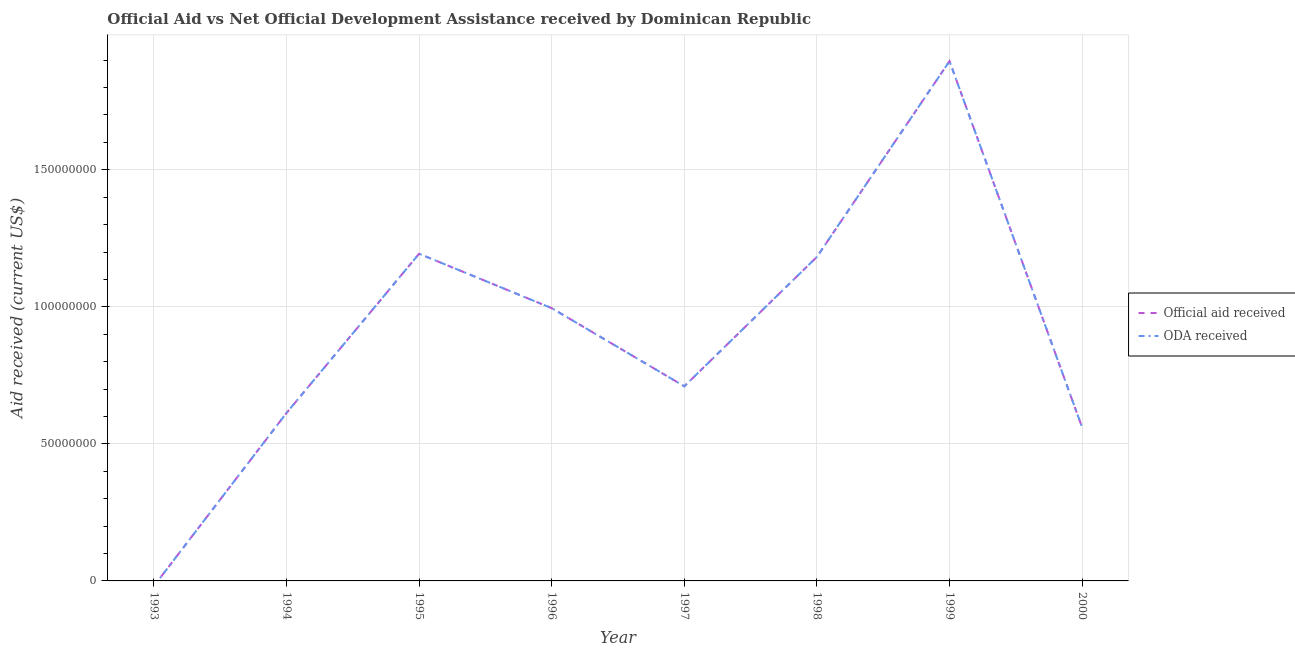How many different coloured lines are there?
Your answer should be very brief. 2. What is the official aid received in 1994?
Give a very brief answer. 6.13e+07. Across all years, what is the maximum oda received?
Your response must be concise. 1.90e+08. In which year was the official aid received maximum?
Keep it short and to the point. 1999. What is the total oda received in the graph?
Keep it short and to the point. 7.15e+08. What is the difference between the official aid received in 1995 and that in 1999?
Ensure brevity in your answer.  -7.03e+07. What is the difference between the official aid received in 1997 and the oda received in 1994?
Offer a very short reply. 9.74e+06. What is the average official aid received per year?
Give a very brief answer. 8.94e+07. In the year 1997, what is the difference between the official aid received and oda received?
Keep it short and to the point. 0. In how many years, is the oda received greater than 160000000 US$?
Make the answer very short. 1. What is the ratio of the oda received in 1994 to that in 1996?
Ensure brevity in your answer.  0.62. What is the difference between the highest and the second highest official aid received?
Your response must be concise. 7.03e+07. What is the difference between the highest and the lowest official aid received?
Provide a short and direct response. 1.90e+08. Does the official aid received monotonically increase over the years?
Offer a terse response. No. Is the oda received strictly greater than the official aid received over the years?
Your answer should be compact. No. How many lines are there?
Provide a short and direct response. 2. What is the difference between two consecutive major ticks on the Y-axis?
Offer a terse response. 5.00e+07. Does the graph contain any zero values?
Offer a terse response. Yes. Does the graph contain grids?
Offer a very short reply. Yes. How are the legend labels stacked?
Offer a terse response. Vertical. What is the title of the graph?
Your response must be concise. Official Aid vs Net Official Development Assistance received by Dominican Republic . What is the label or title of the X-axis?
Make the answer very short. Year. What is the label or title of the Y-axis?
Provide a short and direct response. Aid received (current US$). What is the Aid received (current US$) in Official aid received in 1993?
Your response must be concise. 0. What is the Aid received (current US$) in Official aid received in 1994?
Provide a succinct answer. 6.13e+07. What is the Aid received (current US$) in ODA received in 1994?
Your answer should be compact. 6.13e+07. What is the Aid received (current US$) in Official aid received in 1995?
Offer a very short reply. 1.19e+08. What is the Aid received (current US$) in ODA received in 1995?
Your answer should be compact. 1.19e+08. What is the Aid received (current US$) of Official aid received in 1996?
Keep it short and to the point. 9.95e+07. What is the Aid received (current US$) of ODA received in 1996?
Offer a terse response. 9.95e+07. What is the Aid received (current US$) of Official aid received in 1997?
Your response must be concise. 7.10e+07. What is the Aid received (current US$) of ODA received in 1997?
Your answer should be compact. 7.10e+07. What is the Aid received (current US$) of Official aid received in 1998?
Your answer should be very brief. 1.18e+08. What is the Aid received (current US$) in ODA received in 1998?
Ensure brevity in your answer.  1.18e+08. What is the Aid received (current US$) of Official aid received in 1999?
Your answer should be compact. 1.90e+08. What is the Aid received (current US$) of ODA received in 1999?
Your answer should be very brief. 1.90e+08. What is the Aid received (current US$) of Official aid received in 2000?
Provide a short and direct response. 5.60e+07. What is the Aid received (current US$) of ODA received in 2000?
Provide a short and direct response. 5.60e+07. Across all years, what is the maximum Aid received (current US$) in Official aid received?
Your answer should be very brief. 1.90e+08. Across all years, what is the maximum Aid received (current US$) in ODA received?
Your answer should be very brief. 1.90e+08. Across all years, what is the minimum Aid received (current US$) in ODA received?
Offer a very short reply. 0. What is the total Aid received (current US$) of Official aid received in the graph?
Offer a terse response. 7.15e+08. What is the total Aid received (current US$) in ODA received in the graph?
Give a very brief answer. 7.15e+08. What is the difference between the Aid received (current US$) of Official aid received in 1994 and that in 1995?
Your answer should be compact. -5.81e+07. What is the difference between the Aid received (current US$) in ODA received in 1994 and that in 1995?
Your answer should be compact. -5.81e+07. What is the difference between the Aid received (current US$) of Official aid received in 1994 and that in 1996?
Offer a terse response. -3.82e+07. What is the difference between the Aid received (current US$) in ODA received in 1994 and that in 1996?
Your response must be concise. -3.82e+07. What is the difference between the Aid received (current US$) of Official aid received in 1994 and that in 1997?
Ensure brevity in your answer.  -9.74e+06. What is the difference between the Aid received (current US$) of ODA received in 1994 and that in 1997?
Offer a very short reply. -9.74e+06. What is the difference between the Aid received (current US$) of Official aid received in 1994 and that in 1998?
Offer a terse response. -5.70e+07. What is the difference between the Aid received (current US$) of ODA received in 1994 and that in 1998?
Offer a terse response. -5.70e+07. What is the difference between the Aid received (current US$) of Official aid received in 1994 and that in 1999?
Provide a succinct answer. -1.28e+08. What is the difference between the Aid received (current US$) in ODA received in 1994 and that in 1999?
Keep it short and to the point. -1.28e+08. What is the difference between the Aid received (current US$) of Official aid received in 1994 and that in 2000?
Keep it short and to the point. 5.27e+06. What is the difference between the Aid received (current US$) of ODA received in 1994 and that in 2000?
Offer a very short reply. 5.27e+06. What is the difference between the Aid received (current US$) in Official aid received in 1995 and that in 1996?
Give a very brief answer. 1.98e+07. What is the difference between the Aid received (current US$) of ODA received in 1995 and that in 1996?
Keep it short and to the point. 1.98e+07. What is the difference between the Aid received (current US$) of Official aid received in 1995 and that in 1997?
Your answer should be very brief. 4.84e+07. What is the difference between the Aid received (current US$) in ODA received in 1995 and that in 1997?
Provide a succinct answer. 4.84e+07. What is the difference between the Aid received (current US$) of Official aid received in 1995 and that in 1998?
Offer a terse response. 1.13e+06. What is the difference between the Aid received (current US$) in ODA received in 1995 and that in 1998?
Provide a succinct answer. 1.13e+06. What is the difference between the Aid received (current US$) in Official aid received in 1995 and that in 1999?
Provide a succinct answer. -7.03e+07. What is the difference between the Aid received (current US$) in ODA received in 1995 and that in 1999?
Offer a very short reply. -7.03e+07. What is the difference between the Aid received (current US$) in Official aid received in 1995 and that in 2000?
Your answer should be compact. 6.34e+07. What is the difference between the Aid received (current US$) of ODA received in 1995 and that in 2000?
Your answer should be very brief. 6.34e+07. What is the difference between the Aid received (current US$) of Official aid received in 1996 and that in 1997?
Offer a very short reply. 2.85e+07. What is the difference between the Aid received (current US$) of ODA received in 1996 and that in 1997?
Offer a very short reply. 2.85e+07. What is the difference between the Aid received (current US$) in Official aid received in 1996 and that in 1998?
Your answer should be compact. -1.87e+07. What is the difference between the Aid received (current US$) in ODA received in 1996 and that in 1998?
Provide a succinct answer. -1.87e+07. What is the difference between the Aid received (current US$) of Official aid received in 1996 and that in 1999?
Give a very brief answer. -9.01e+07. What is the difference between the Aid received (current US$) of ODA received in 1996 and that in 1999?
Keep it short and to the point. -9.01e+07. What is the difference between the Aid received (current US$) of Official aid received in 1996 and that in 2000?
Offer a terse response. 4.35e+07. What is the difference between the Aid received (current US$) of ODA received in 1996 and that in 2000?
Make the answer very short. 4.35e+07. What is the difference between the Aid received (current US$) in Official aid received in 1997 and that in 1998?
Your answer should be compact. -4.72e+07. What is the difference between the Aid received (current US$) in ODA received in 1997 and that in 1998?
Ensure brevity in your answer.  -4.72e+07. What is the difference between the Aid received (current US$) of Official aid received in 1997 and that in 1999?
Provide a succinct answer. -1.19e+08. What is the difference between the Aid received (current US$) of ODA received in 1997 and that in 1999?
Offer a very short reply. -1.19e+08. What is the difference between the Aid received (current US$) of Official aid received in 1997 and that in 2000?
Make the answer very short. 1.50e+07. What is the difference between the Aid received (current US$) of ODA received in 1997 and that in 2000?
Your answer should be compact. 1.50e+07. What is the difference between the Aid received (current US$) in Official aid received in 1998 and that in 1999?
Provide a succinct answer. -7.14e+07. What is the difference between the Aid received (current US$) in ODA received in 1998 and that in 1999?
Your response must be concise. -7.14e+07. What is the difference between the Aid received (current US$) of Official aid received in 1998 and that in 2000?
Your answer should be very brief. 6.22e+07. What is the difference between the Aid received (current US$) in ODA received in 1998 and that in 2000?
Offer a terse response. 6.22e+07. What is the difference between the Aid received (current US$) in Official aid received in 1999 and that in 2000?
Provide a short and direct response. 1.34e+08. What is the difference between the Aid received (current US$) in ODA received in 1999 and that in 2000?
Your response must be concise. 1.34e+08. What is the difference between the Aid received (current US$) of Official aid received in 1994 and the Aid received (current US$) of ODA received in 1995?
Your answer should be very brief. -5.81e+07. What is the difference between the Aid received (current US$) of Official aid received in 1994 and the Aid received (current US$) of ODA received in 1996?
Your answer should be compact. -3.82e+07. What is the difference between the Aid received (current US$) of Official aid received in 1994 and the Aid received (current US$) of ODA received in 1997?
Your answer should be compact. -9.74e+06. What is the difference between the Aid received (current US$) of Official aid received in 1994 and the Aid received (current US$) of ODA received in 1998?
Give a very brief answer. -5.70e+07. What is the difference between the Aid received (current US$) of Official aid received in 1994 and the Aid received (current US$) of ODA received in 1999?
Your answer should be compact. -1.28e+08. What is the difference between the Aid received (current US$) in Official aid received in 1994 and the Aid received (current US$) in ODA received in 2000?
Make the answer very short. 5.27e+06. What is the difference between the Aid received (current US$) of Official aid received in 1995 and the Aid received (current US$) of ODA received in 1996?
Offer a terse response. 1.98e+07. What is the difference between the Aid received (current US$) in Official aid received in 1995 and the Aid received (current US$) in ODA received in 1997?
Provide a short and direct response. 4.84e+07. What is the difference between the Aid received (current US$) of Official aid received in 1995 and the Aid received (current US$) of ODA received in 1998?
Keep it short and to the point. 1.13e+06. What is the difference between the Aid received (current US$) of Official aid received in 1995 and the Aid received (current US$) of ODA received in 1999?
Provide a short and direct response. -7.03e+07. What is the difference between the Aid received (current US$) of Official aid received in 1995 and the Aid received (current US$) of ODA received in 2000?
Offer a terse response. 6.34e+07. What is the difference between the Aid received (current US$) of Official aid received in 1996 and the Aid received (current US$) of ODA received in 1997?
Your answer should be very brief. 2.85e+07. What is the difference between the Aid received (current US$) of Official aid received in 1996 and the Aid received (current US$) of ODA received in 1998?
Make the answer very short. -1.87e+07. What is the difference between the Aid received (current US$) of Official aid received in 1996 and the Aid received (current US$) of ODA received in 1999?
Give a very brief answer. -9.01e+07. What is the difference between the Aid received (current US$) in Official aid received in 1996 and the Aid received (current US$) in ODA received in 2000?
Keep it short and to the point. 4.35e+07. What is the difference between the Aid received (current US$) in Official aid received in 1997 and the Aid received (current US$) in ODA received in 1998?
Offer a very short reply. -4.72e+07. What is the difference between the Aid received (current US$) in Official aid received in 1997 and the Aid received (current US$) in ODA received in 1999?
Make the answer very short. -1.19e+08. What is the difference between the Aid received (current US$) of Official aid received in 1997 and the Aid received (current US$) of ODA received in 2000?
Give a very brief answer. 1.50e+07. What is the difference between the Aid received (current US$) of Official aid received in 1998 and the Aid received (current US$) of ODA received in 1999?
Keep it short and to the point. -7.14e+07. What is the difference between the Aid received (current US$) in Official aid received in 1998 and the Aid received (current US$) in ODA received in 2000?
Your response must be concise. 6.22e+07. What is the difference between the Aid received (current US$) of Official aid received in 1999 and the Aid received (current US$) of ODA received in 2000?
Provide a succinct answer. 1.34e+08. What is the average Aid received (current US$) of Official aid received per year?
Provide a short and direct response. 8.94e+07. What is the average Aid received (current US$) in ODA received per year?
Keep it short and to the point. 8.94e+07. In the year 1996, what is the difference between the Aid received (current US$) in Official aid received and Aid received (current US$) in ODA received?
Ensure brevity in your answer.  0. In the year 1998, what is the difference between the Aid received (current US$) of Official aid received and Aid received (current US$) of ODA received?
Offer a terse response. 0. In the year 2000, what is the difference between the Aid received (current US$) in Official aid received and Aid received (current US$) in ODA received?
Give a very brief answer. 0. What is the ratio of the Aid received (current US$) of Official aid received in 1994 to that in 1995?
Keep it short and to the point. 0.51. What is the ratio of the Aid received (current US$) in ODA received in 1994 to that in 1995?
Give a very brief answer. 0.51. What is the ratio of the Aid received (current US$) of Official aid received in 1994 to that in 1996?
Provide a succinct answer. 0.62. What is the ratio of the Aid received (current US$) in ODA received in 1994 to that in 1996?
Provide a short and direct response. 0.62. What is the ratio of the Aid received (current US$) in Official aid received in 1994 to that in 1997?
Provide a short and direct response. 0.86. What is the ratio of the Aid received (current US$) of ODA received in 1994 to that in 1997?
Offer a terse response. 0.86. What is the ratio of the Aid received (current US$) of Official aid received in 1994 to that in 1998?
Offer a very short reply. 0.52. What is the ratio of the Aid received (current US$) in ODA received in 1994 to that in 1998?
Your answer should be very brief. 0.52. What is the ratio of the Aid received (current US$) of Official aid received in 1994 to that in 1999?
Offer a very short reply. 0.32. What is the ratio of the Aid received (current US$) in ODA received in 1994 to that in 1999?
Offer a very short reply. 0.32. What is the ratio of the Aid received (current US$) in Official aid received in 1994 to that in 2000?
Provide a succinct answer. 1.09. What is the ratio of the Aid received (current US$) of ODA received in 1994 to that in 2000?
Keep it short and to the point. 1.09. What is the ratio of the Aid received (current US$) of Official aid received in 1995 to that in 1996?
Your answer should be very brief. 1.2. What is the ratio of the Aid received (current US$) in ODA received in 1995 to that in 1996?
Your answer should be very brief. 1.2. What is the ratio of the Aid received (current US$) of Official aid received in 1995 to that in 1997?
Your answer should be compact. 1.68. What is the ratio of the Aid received (current US$) in ODA received in 1995 to that in 1997?
Make the answer very short. 1.68. What is the ratio of the Aid received (current US$) of Official aid received in 1995 to that in 1998?
Ensure brevity in your answer.  1.01. What is the ratio of the Aid received (current US$) of ODA received in 1995 to that in 1998?
Keep it short and to the point. 1.01. What is the ratio of the Aid received (current US$) in Official aid received in 1995 to that in 1999?
Your answer should be very brief. 0.63. What is the ratio of the Aid received (current US$) in ODA received in 1995 to that in 1999?
Ensure brevity in your answer.  0.63. What is the ratio of the Aid received (current US$) of Official aid received in 1995 to that in 2000?
Your answer should be compact. 2.13. What is the ratio of the Aid received (current US$) in ODA received in 1995 to that in 2000?
Provide a succinct answer. 2.13. What is the ratio of the Aid received (current US$) in Official aid received in 1996 to that in 1997?
Provide a succinct answer. 1.4. What is the ratio of the Aid received (current US$) of ODA received in 1996 to that in 1997?
Give a very brief answer. 1.4. What is the ratio of the Aid received (current US$) in Official aid received in 1996 to that in 1998?
Keep it short and to the point. 0.84. What is the ratio of the Aid received (current US$) in ODA received in 1996 to that in 1998?
Keep it short and to the point. 0.84. What is the ratio of the Aid received (current US$) of Official aid received in 1996 to that in 1999?
Ensure brevity in your answer.  0.52. What is the ratio of the Aid received (current US$) of ODA received in 1996 to that in 1999?
Offer a terse response. 0.52. What is the ratio of the Aid received (current US$) in Official aid received in 1996 to that in 2000?
Your response must be concise. 1.78. What is the ratio of the Aid received (current US$) in ODA received in 1996 to that in 2000?
Your response must be concise. 1.78. What is the ratio of the Aid received (current US$) of Official aid received in 1997 to that in 1998?
Ensure brevity in your answer.  0.6. What is the ratio of the Aid received (current US$) in ODA received in 1997 to that in 1998?
Your answer should be compact. 0.6. What is the ratio of the Aid received (current US$) in Official aid received in 1997 to that in 1999?
Offer a terse response. 0.37. What is the ratio of the Aid received (current US$) in ODA received in 1997 to that in 1999?
Keep it short and to the point. 0.37. What is the ratio of the Aid received (current US$) in Official aid received in 1997 to that in 2000?
Provide a succinct answer. 1.27. What is the ratio of the Aid received (current US$) in ODA received in 1997 to that in 2000?
Ensure brevity in your answer.  1.27. What is the ratio of the Aid received (current US$) of Official aid received in 1998 to that in 1999?
Offer a very short reply. 0.62. What is the ratio of the Aid received (current US$) of ODA received in 1998 to that in 1999?
Keep it short and to the point. 0.62. What is the ratio of the Aid received (current US$) of Official aid received in 1998 to that in 2000?
Keep it short and to the point. 2.11. What is the ratio of the Aid received (current US$) of ODA received in 1998 to that in 2000?
Provide a short and direct response. 2.11. What is the ratio of the Aid received (current US$) of Official aid received in 1999 to that in 2000?
Offer a very short reply. 3.39. What is the ratio of the Aid received (current US$) of ODA received in 1999 to that in 2000?
Provide a succinct answer. 3.39. What is the difference between the highest and the second highest Aid received (current US$) in Official aid received?
Ensure brevity in your answer.  7.03e+07. What is the difference between the highest and the second highest Aid received (current US$) of ODA received?
Keep it short and to the point. 7.03e+07. What is the difference between the highest and the lowest Aid received (current US$) of Official aid received?
Give a very brief answer. 1.90e+08. What is the difference between the highest and the lowest Aid received (current US$) of ODA received?
Provide a succinct answer. 1.90e+08. 